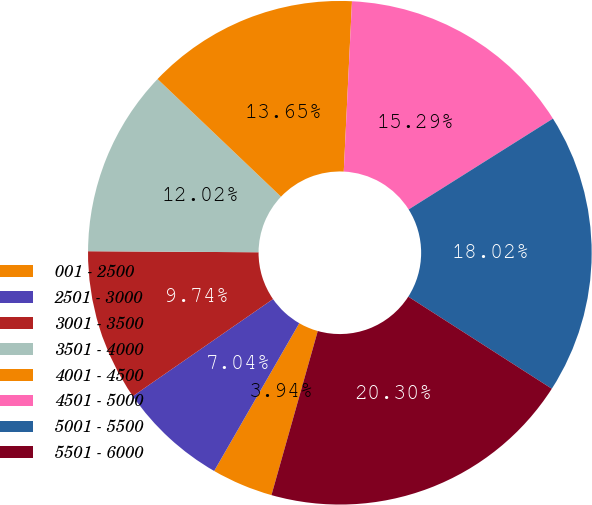Convert chart to OTSL. <chart><loc_0><loc_0><loc_500><loc_500><pie_chart><fcel>001 - 2500<fcel>2501 - 3000<fcel>3001 - 3500<fcel>3501 - 4000<fcel>4001 - 4500<fcel>4501 - 5000<fcel>5001 - 5500<fcel>5501 - 6000<nl><fcel>3.94%<fcel>7.04%<fcel>9.74%<fcel>12.02%<fcel>13.65%<fcel>15.29%<fcel>18.02%<fcel>20.3%<nl></chart> 